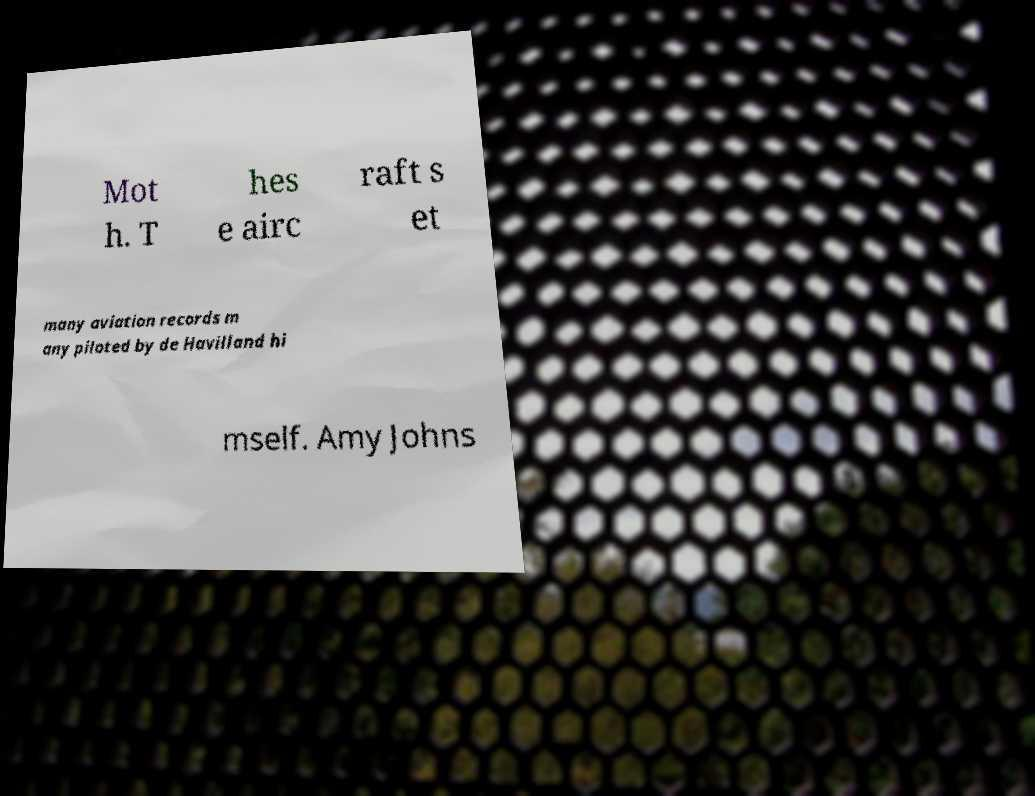Please read and relay the text visible in this image. What does it say? Mot h. T hes e airc raft s et many aviation records m any piloted by de Havilland hi mself. Amy Johns 